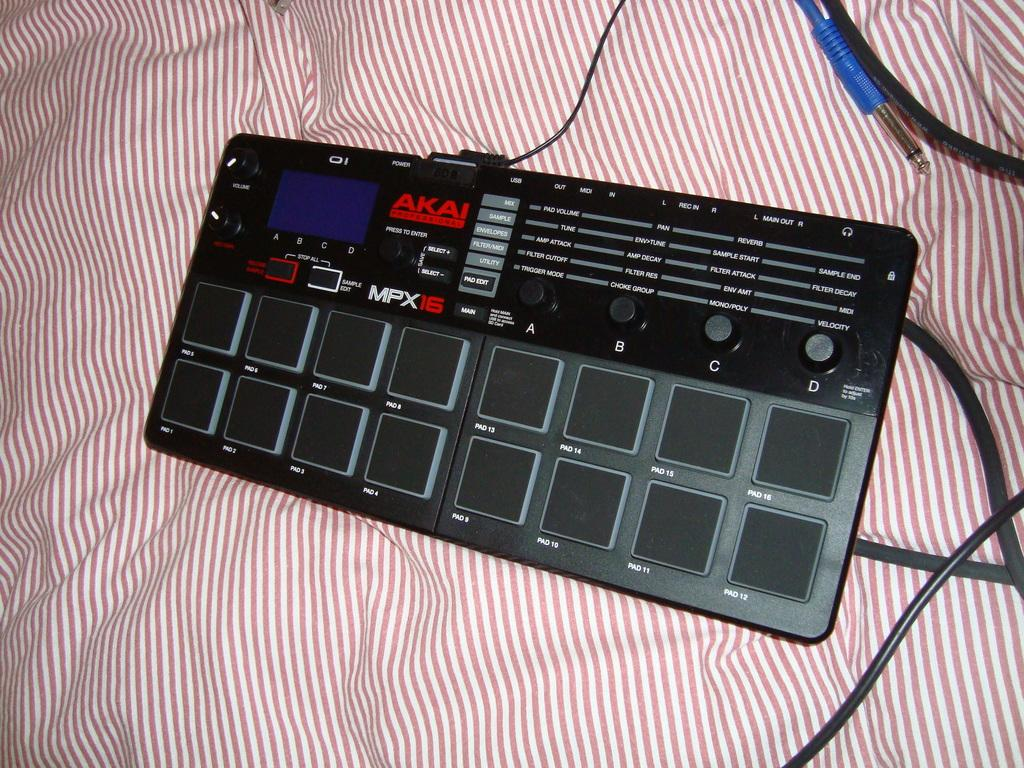What is the main object in the image? There is a device in the image. What are the cables attached to in the image? The cables are attached to the device. What is the surface on which the device and cables are placed? The device and cables are placed on a cloth surface. What type of band is performing in the image? There is no band present in the image; it features a device with cables on a cloth surface. How many members are on the team in the image? There is no team present in the image; it features a device with cables on a cloth surface. 